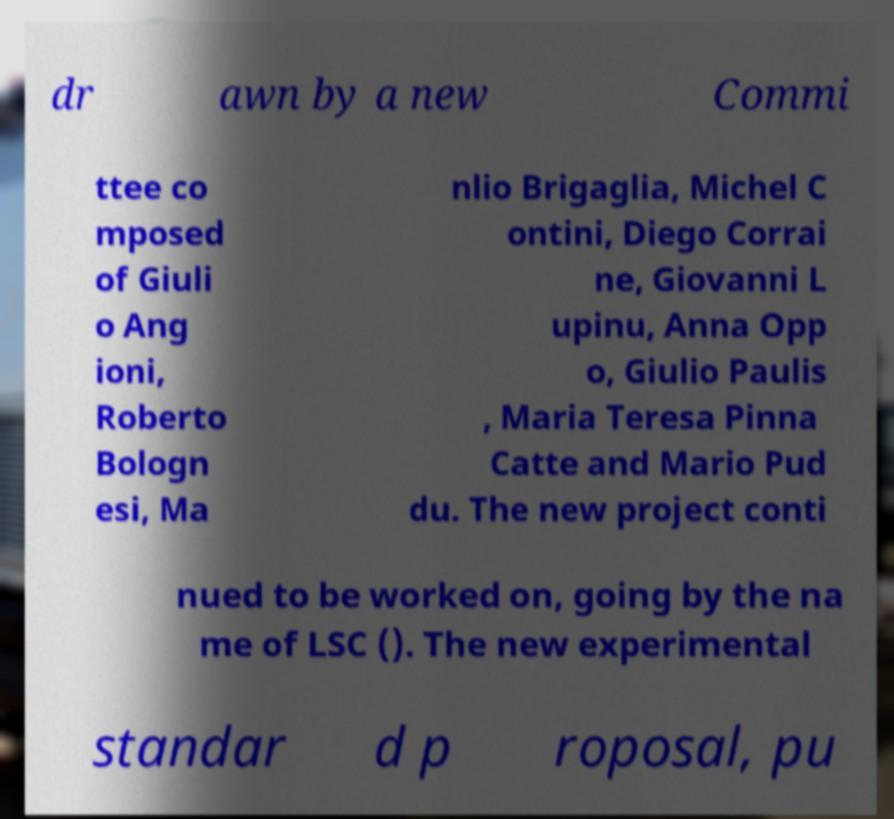I need the written content from this picture converted into text. Can you do that? dr awn by a new Commi ttee co mposed of Giuli o Ang ioni, Roberto Bologn esi, Ma nlio Brigaglia, Michel C ontini, Diego Corrai ne, Giovanni L upinu, Anna Opp o, Giulio Paulis , Maria Teresa Pinna Catte and Mario Pud du. The new project conti nued to be worked on, going by the na me of LSC (). The new experimental standar d p roposal, pu 